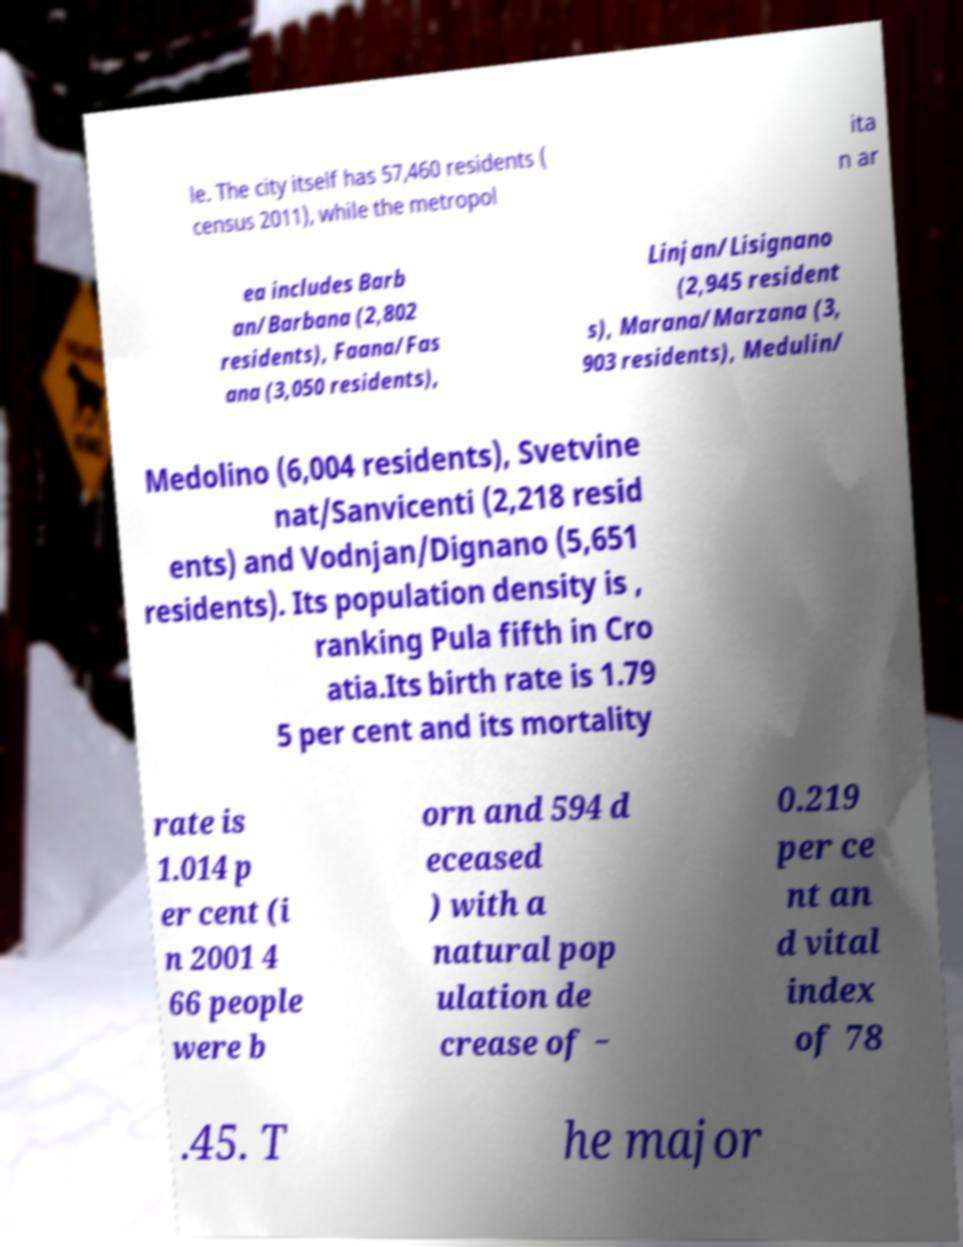For documentation purposes, I need the text within this image transcribed. Could you provide that? le. The city itself has 57,460 residents ( census 2011), while the metropol ita n ar ea includes Barb an/Barbana (2,802 residents), Faana/Fas ana (3,050 residents), Linjan/Lisignano (2,945 resident s), Marana/Marzana (3, 903 residents), Medulin/ Medolino (6,004 residents), Svetvine nat/Sanvicenti (2,218 resid ents) and Vodnjan/Dignano (5,651 residents). Its population density is , ranking Pula fifth in Cro atia.Its birth rate is 1.79 5 per cent and its mortality rate is 1.014 p er cent (i n 2001 4 66 people were b orn and 594 d eceased ) with a natural pop ulation de crease of − 0.219 per ce nt an d vital index of 78 .45. T he major 